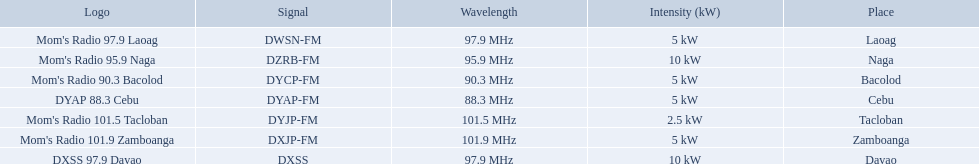What are all of the frequencies? 97.9 MHz, 95.9 MHz, 90.3 MHz, 88.3 MHz, 101.5 MHz, 101.9 MHz, 97.9 MHz. Which of these frequencies is the lowest? 88.3 MHz. Which branding does this frequency belong to? DYAP 88.3 Cebu. 